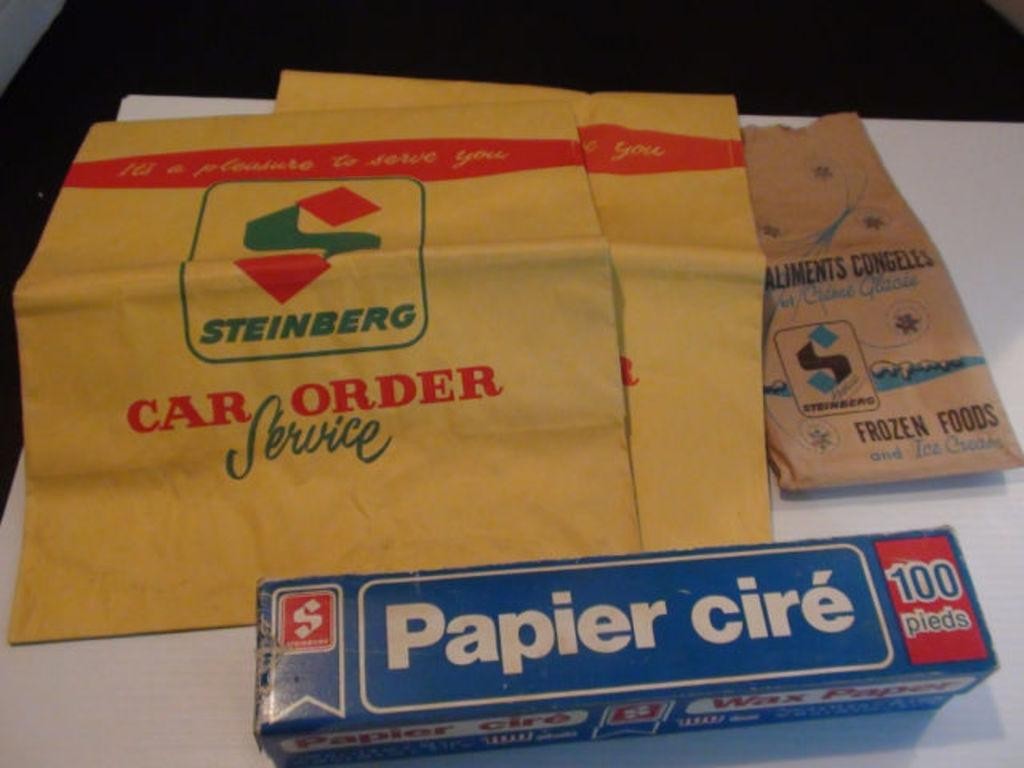Provide a one-sentence caption for the provided image. a box of Papier cire sitting in front of some Steinberg bags. 